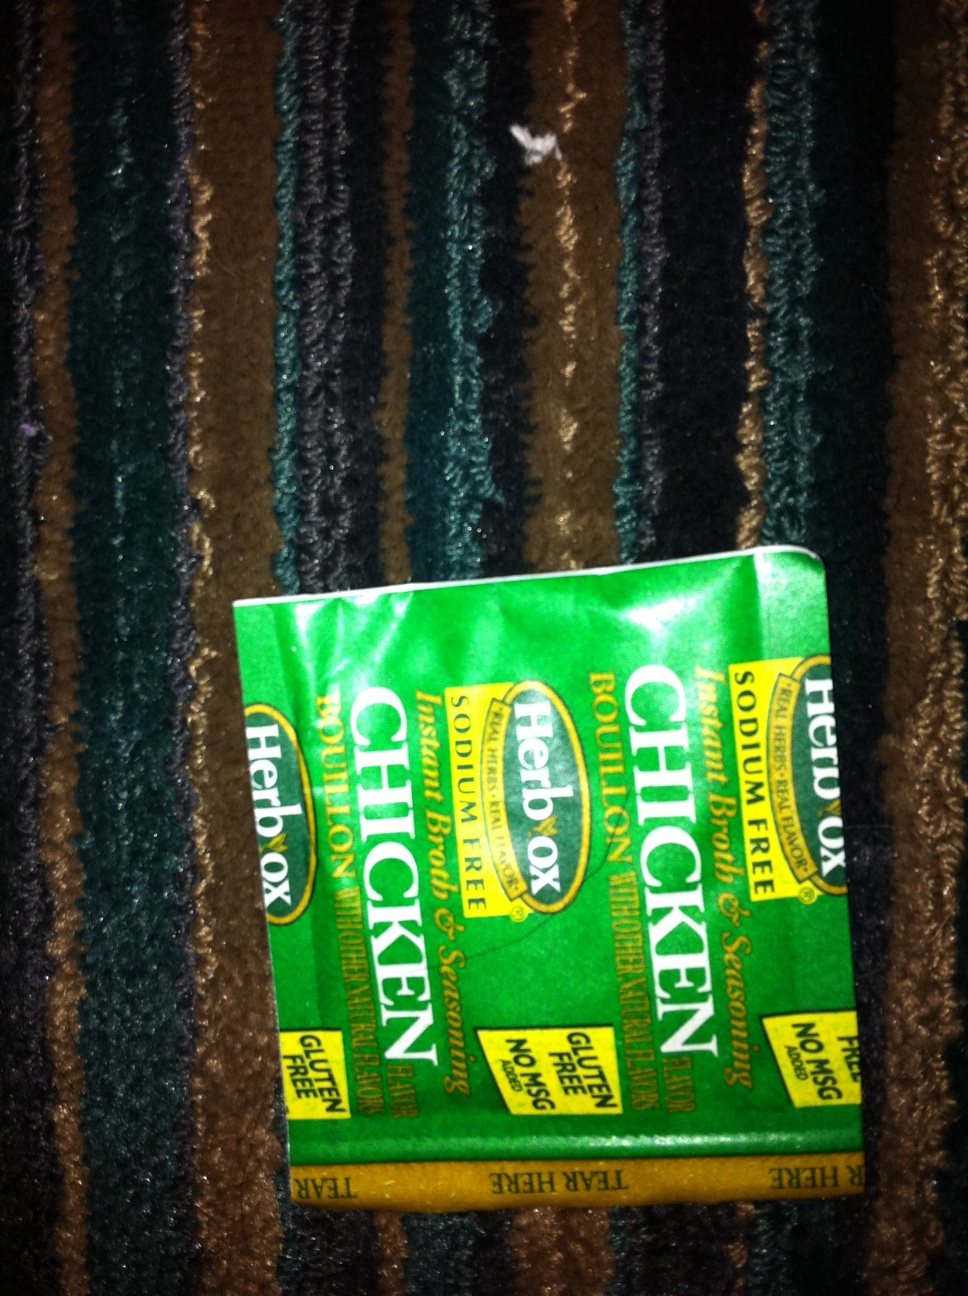What ingredients are in this bouillon? The ingredients typically found in Herbox Chicken Bouillon include salt, sugar, maltodextrin, cornstarch, chicken fat, dried chicken, yeast extract, natural flavor, and spices. For exact details, please refer to the package. 